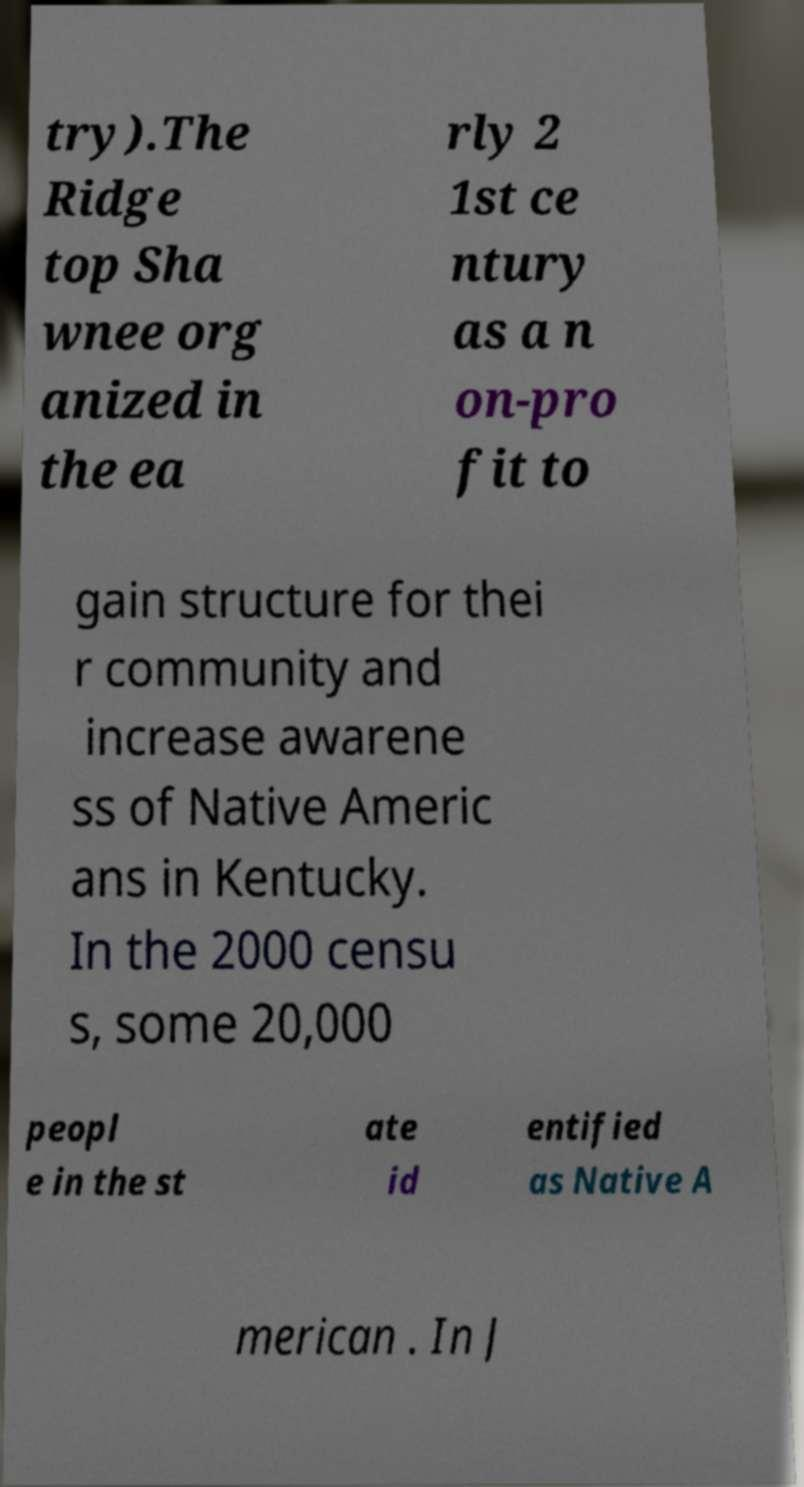Please identify and transcribe the text found in this image. try).The Ridge top Sha wnee org anized in the ea rly 2 1st ce ntury as a n on-pro fit to gain structure for thei r community and increase awarene ss of Native Americ ans in Kentucky. In the 2000 censu s, some 20,000 peopl e in the st ate id entified as Native A merican . In J 